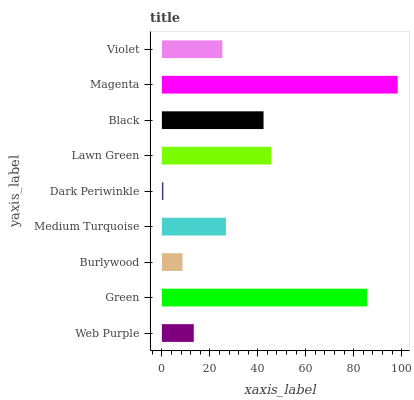Is Dark Periwinkle the minimum?
Answer yes or no. Yes. Is Magenta the maximum?
Answer yes or no. Yes. Is Green the minimum?
Answer yes or no. No. Is Green the maximum?
Answer yes or no. No. Is Green greater than Web Purple?
Answer yes or no. Yes. Is Web Purple less than Green?
Answer yes or no. Yes. Is Web Purple greater than Green?
Answer yes or no. No. Is Green less than Web Purple?
Answer yes or no. No. Is Medium Turquoise the high median?
Answer yes or no. Yes. Is Medium Turquoise the low median?
Answer yes or no. Yes. Is Burlywood the high median?
Answer yes or no. No. Is Burlywood the low median?
Answer yes or no. No. 